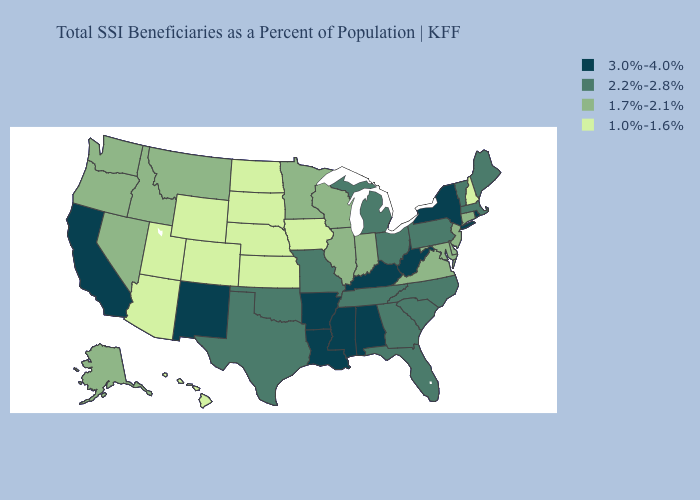Does Texas have a lower value than Michigan?
Short answer required. No. Does Washington have the same value as Iowa?
Concise answer only. No. Name the states that have a value in the range 3.0%-4.0%?
Quick response, please. Alabama, Arkansas, California, Kentucky, Louisiana, Mississippi, New Mexico, New York, Rhode Island, West Virginia. What is the value of Hawaii?
Answer briefly. 1.0%-1.6%. What is the value of New Mexico?
Short answer required. 3.0%-4.0%. What is the lowest value in the USA?
Give a very brief answer. 1.0%-1.6%. Among the states that border New York , which have the lowest value?
Quick response, please. Connecticut, New Jersey. What is the value of South Dakota?
Quick response, please. 1.0%-1.6%. What is the value of Iowa?
Quick response, please. 1.0%-1.6%. Name the states that have a value in the range 1.7%-2.1%?
Concise answer only. Alaska, Connecticut, Delaware, Idaho, Illinois, Indiana, Maryland, Minnesota, Montana, Nevada, New Jersey, Oregon, Virginia, Washington, Wisconsin. What is the value of South Dakota?
Write a very short answer. 1.0%-1.6%. What is the lowest value in the USA?
Concise answer only. 1.0%-1.6%. Which states have the highest value in the USA?
Be succinct. Alabama, Arkansas, California, Kentucky, Louisiana, Mississippi, New Mexico, New York, Rhode Island, West Virginia. Name the states that have a value in the range 1.7%-2.1%?
Quick response, please. Alaska, Connecticut, Delaware, Idaho, Illinois, Indiana, Maryland, Minnesota, Montana, Nevada, New Jersey, Oregon, Virginia, Washington, Wisconsin. 